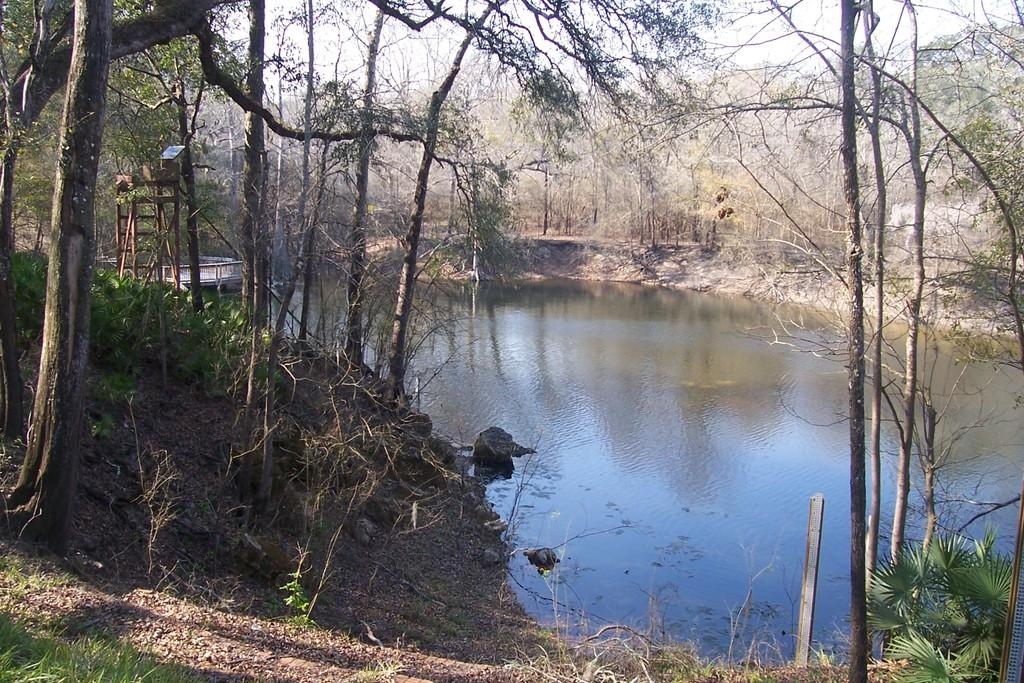What type of vegetation can be seen in the image? There are trees in the image. What else can be seen in the image besides trees? There is water, grass, and metal rods visible in the image. What is visible in the background of the image? The sky is visible in the image. Can you tell if the image was taken during the day or night? The image was likely taken during the day, as the sky is visible. Can you see any rats or nuts in the image? There are no rats or nuts present in the image. Is the image taken during the winter season? The provided facts do not mention any seasonal details, so it cannot be determined if the image was taken during the winter season. 